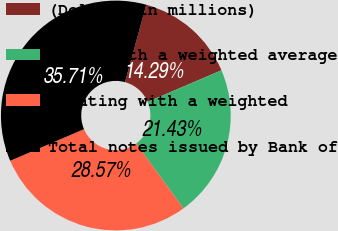<chart> <loc_0><loc_0><loc_500><loc_500><pie_chart><fcel>(Dollars in millions)<fcel>Fixed with a weighted average<fcel>Floating with a weighted<fcel>Total notes issued by Bank of<nl><fcel>14.29%<fcel>21.43%<fcel>28.57%<fcel>35.71%<nl></chart> 